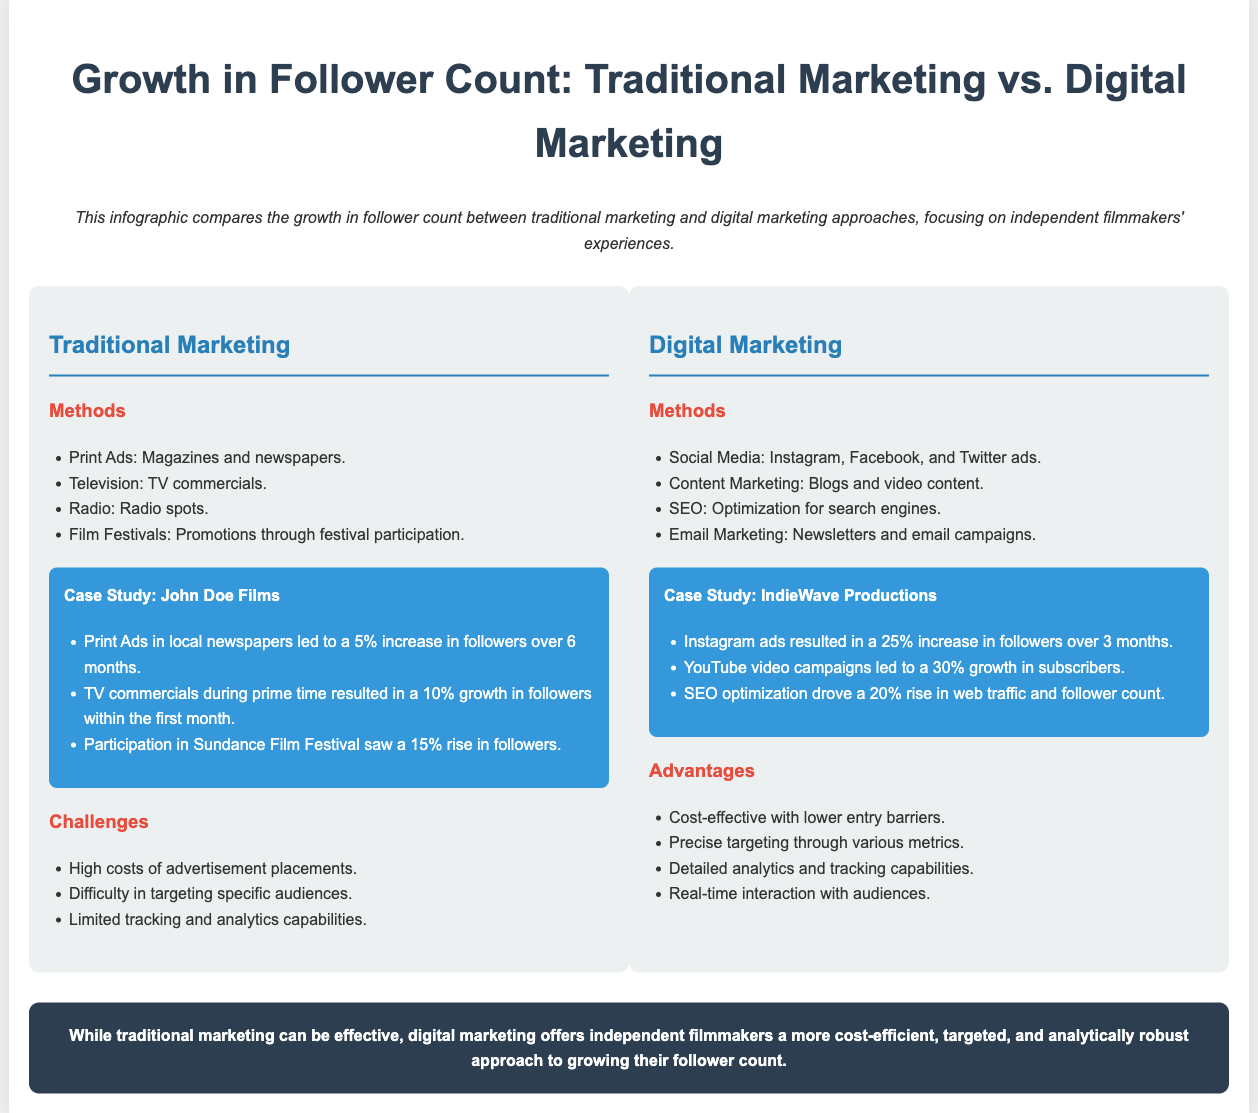What was the follower increase percentage from print ads for John Doe Films? The document states that print ads led to a 5% increase in followers over 6 months for John Doe Films.
Answer: 5% What type of marketing led to a 30% growth in subscribers for IndieWave Productions? The document mentions that YouTube video campaigns resulted in a 30% growth in subscribers for IndieWave Productions.
Answer: YouTube video campaigns Which case study experienced a 15% rise in followers? The case study for John Doe Films shows that participation in Sundance Film Festival resulted in a 15% rise in followers.
Answer: John Doe Films What is one of the advantages of digital marketing mentioned in the infographic? The document lists precise targeting through various metrics as one of the advantages of digital marketing.
Answer: Precise targeting How much did Instagram ads increase followers for IndieWave Productions? The infographic states that Instagram ads resulted in a 25% increase in followers over 3 months for IndieWave Productions.
Answer: 25% What is a challenge faced by traditional marketing according to the document? The document notes that high costs of advertisement placements is a challenge faced by traditional marketing.
Answer: High costs What marketing method led to a 20% rise in web traffic and follower count? According to the document, SEO optimization drove a 20% rise in web traffic and follower count.
Answer: SEO optimization Which marketing approach is highlighted as cost-effective? The infographic indicates that digital marketing is cost-effective with lower entry barriers.
Answer: Digital marketing 